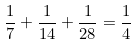Convert formula to latex. <formula><loc_0><loc_0><loc_500><loc_500>\frac { 1 } { 7 } + \frac { 1 } { 1 4 } + \frac { 1 } { 2 8 } = \frac { 1 } { 4 }</formula> 